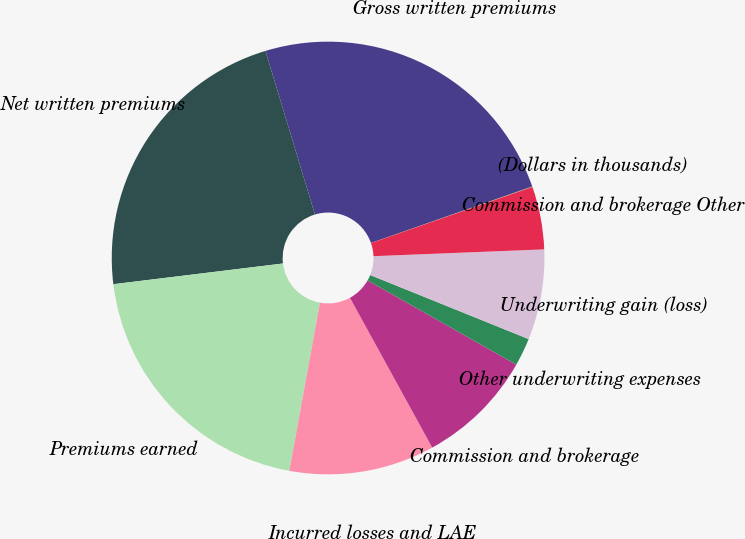Convert chart to OTSL. <chart><loc_0><loc_0><loc_500><loc_500><pie_chart><fcel>(Dollars in thousands)<fcel>Gross written premiums<fcel>Net written premiums<fcel>Premiums earned<fcel>Incurred losses and LAE<fcel>Commission and brokerage<fcel>Other underwriting expenses<fcel>Underwriting gain (loss)<fcel>Commission and brokerage Other<nl><fcel>0.04%<fcel>24.31%<fcel>22.26%<fcel>20.2%<fcel>10.86%<fcel>8.8%<fcel>2.09%<fcel>6.75%<fcel>4.69%<nl></chart> 